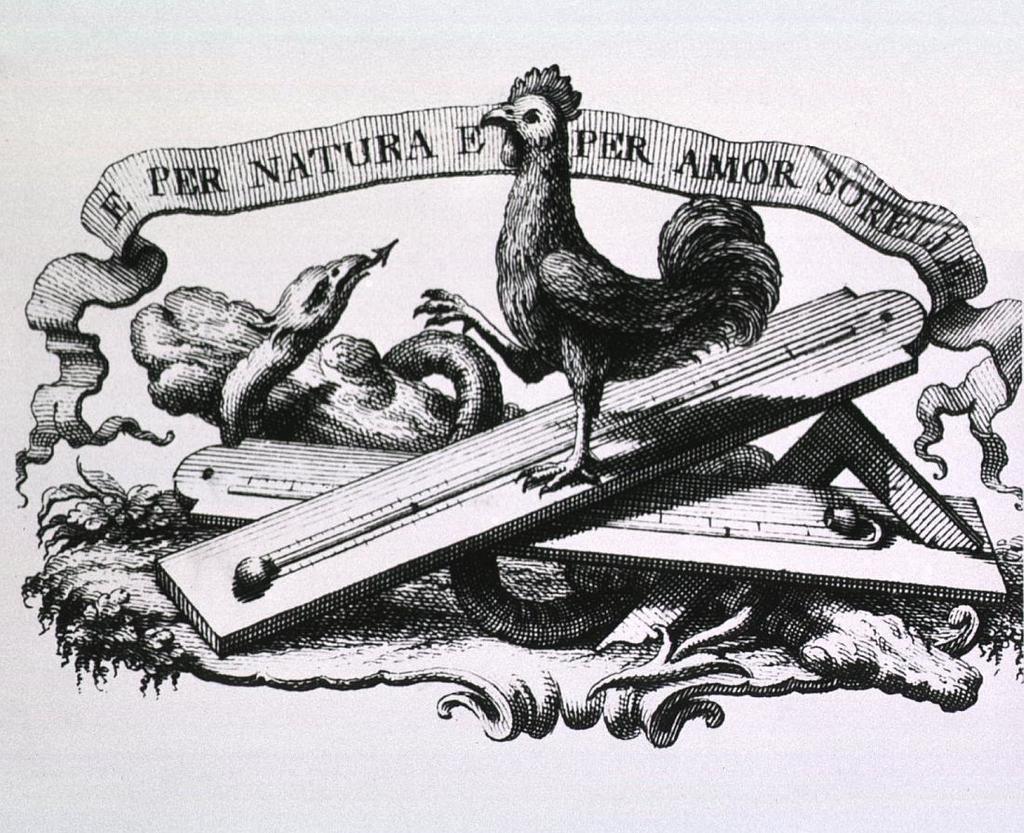Can you describe this image briefly? In this image I can see depiction of a cock and of a snake. I can also see something is written over here and I can see this image is black and white in colour. 